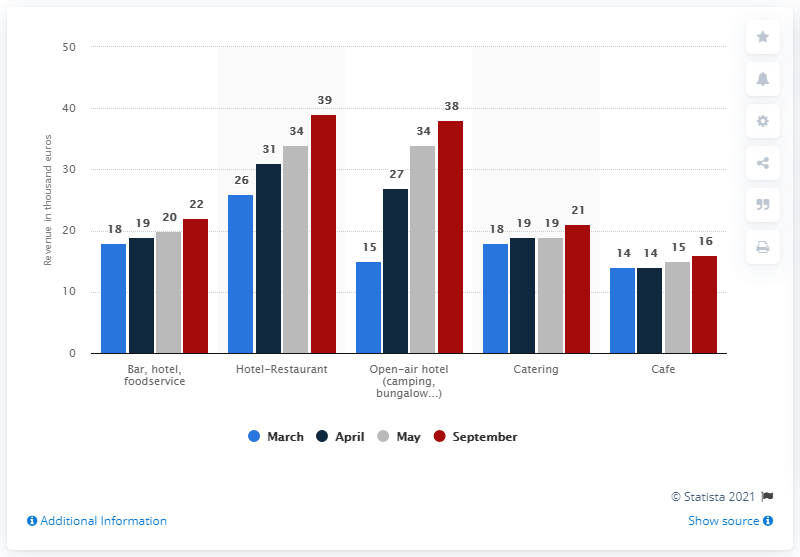Give some essential details in this illustration. The maximum monthly average revenue for the cafe and catering between March and September 2018 was 5,000 euros. The monthly average revenue of the cafe in May 2018 was approximately 15,000 euros. 